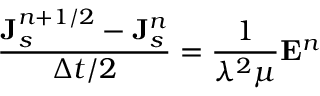<formula> <loc_0><loc_0><loc_500><loc_500>\frac { { J } _ { s } ^ { n + 1 / 2 } - { J } _ { s } ^ { n } } { \Delta t / 2 } = \frac { 1 } { \lambda ^ { 2 } \mu } { E } ^ { n }</formula> 